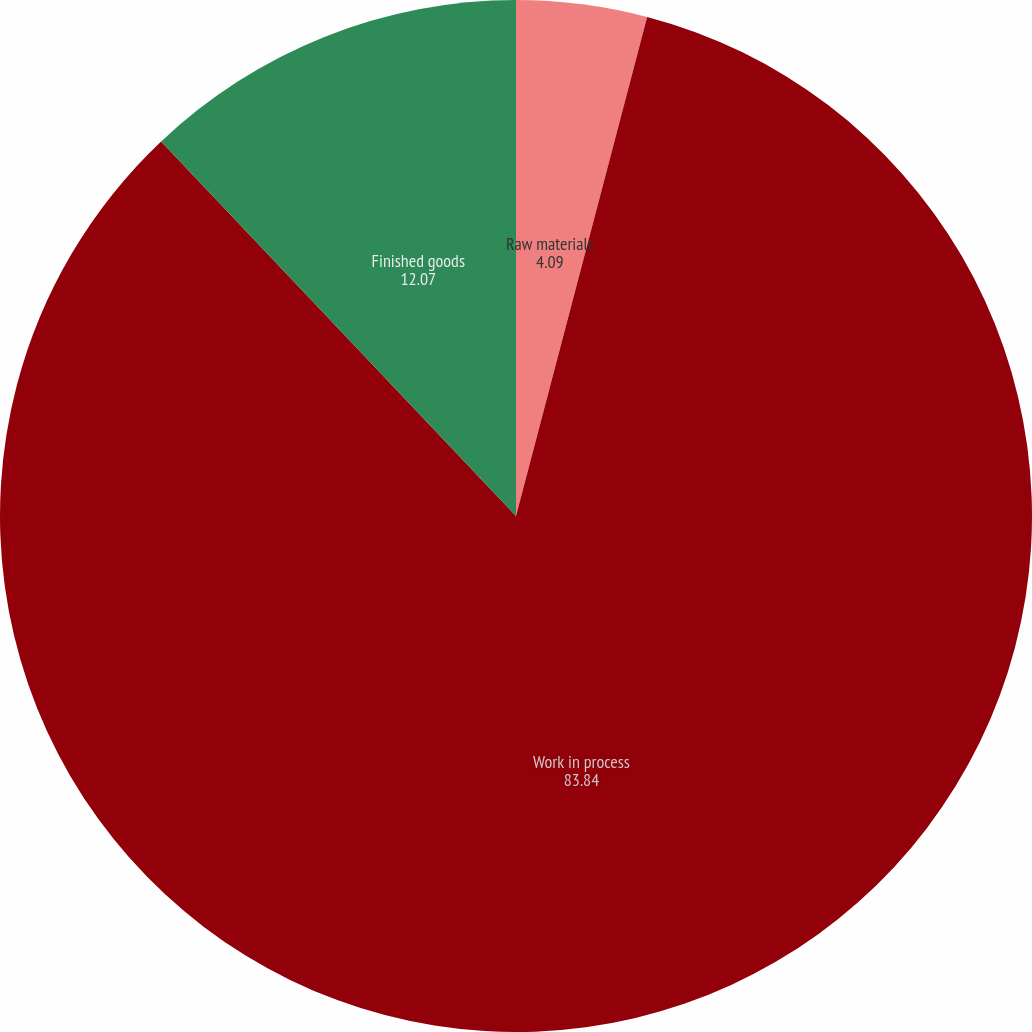<chart> <loc_0><loc_0><loc_500><loc_500><pie_chart><fcel>Raw materials<fcel>Work in process<fcel>Finished goods<nl><fcel>4.09%<fcel>83.84%<fcel>12.07%<nl></chart> 